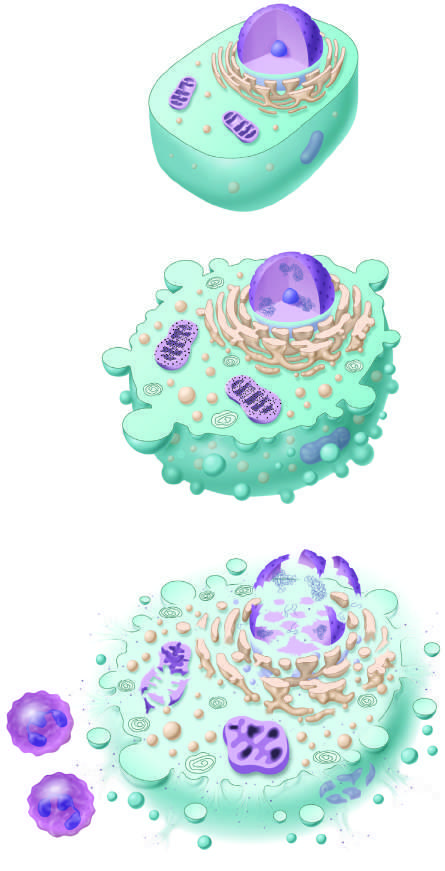what are illustrated?
Answer the question using a single word or phrase. The principal cellular alterations that characterize reversible cell injury and necrosis 